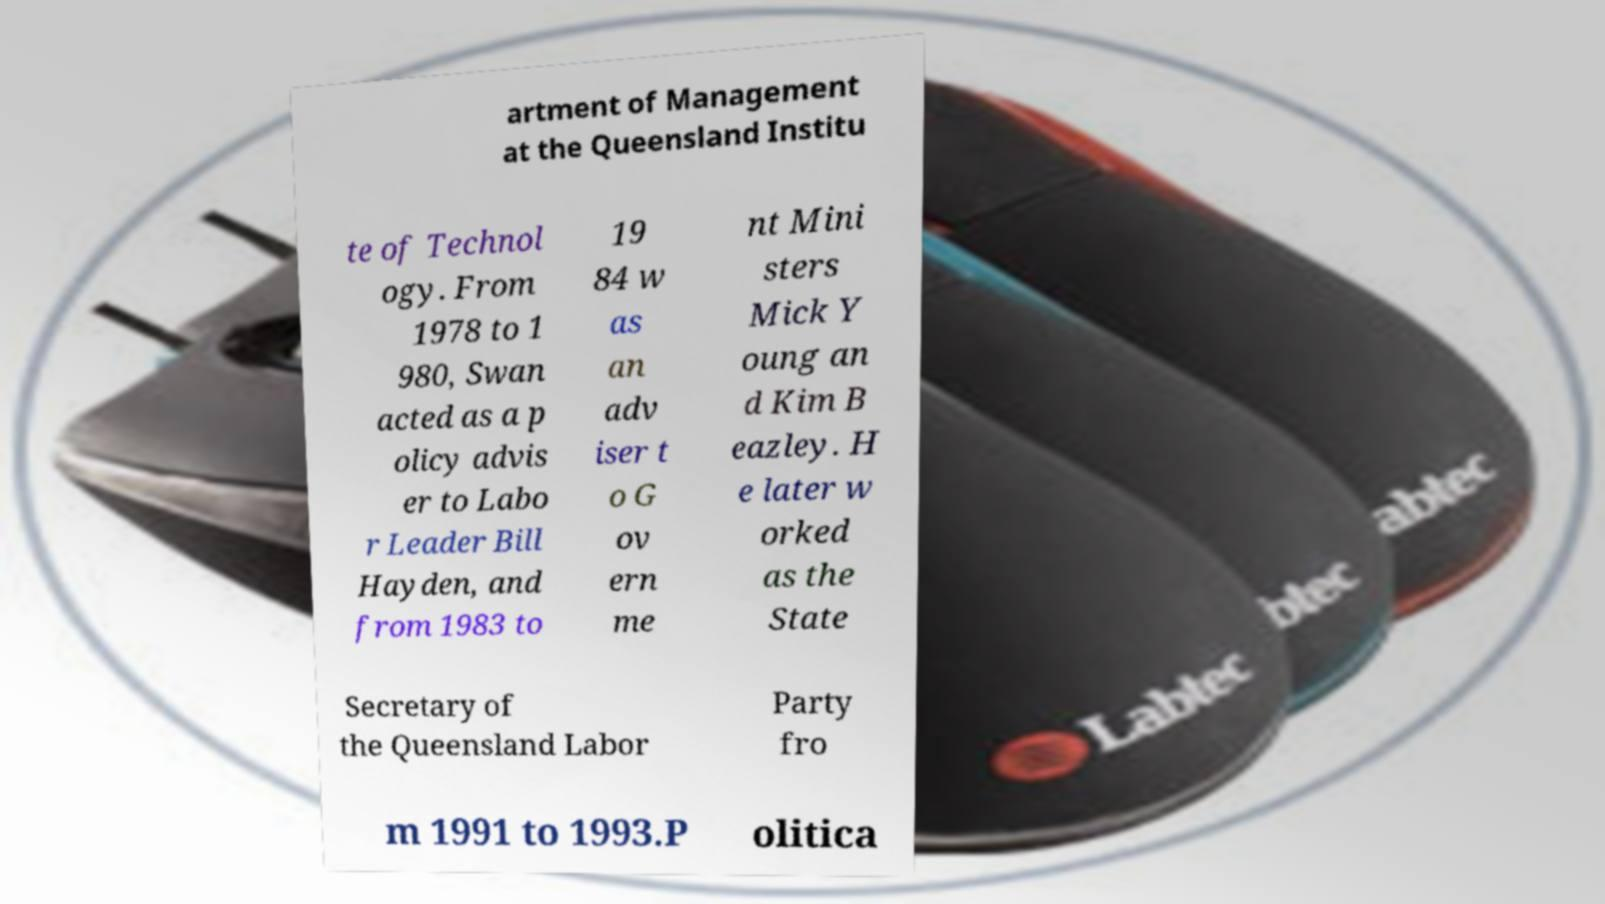What messages or text are displayed in this image? I need them in a readable, typed format. artment of Management at the Queensland Institu te of Technol ogy. From 1978 to 1 980, Swan acted as a p olicy advis er to Labo r Leader Bill Hayden, and from 1983 to 19 84 w as an adv iser t o G ov ern me nt Mini sters Mick Y oung an d Kim B eazley. H e later w orked as the State Secretary of the Queensland Labor Party fro m 1991 to 1993.P olitica 